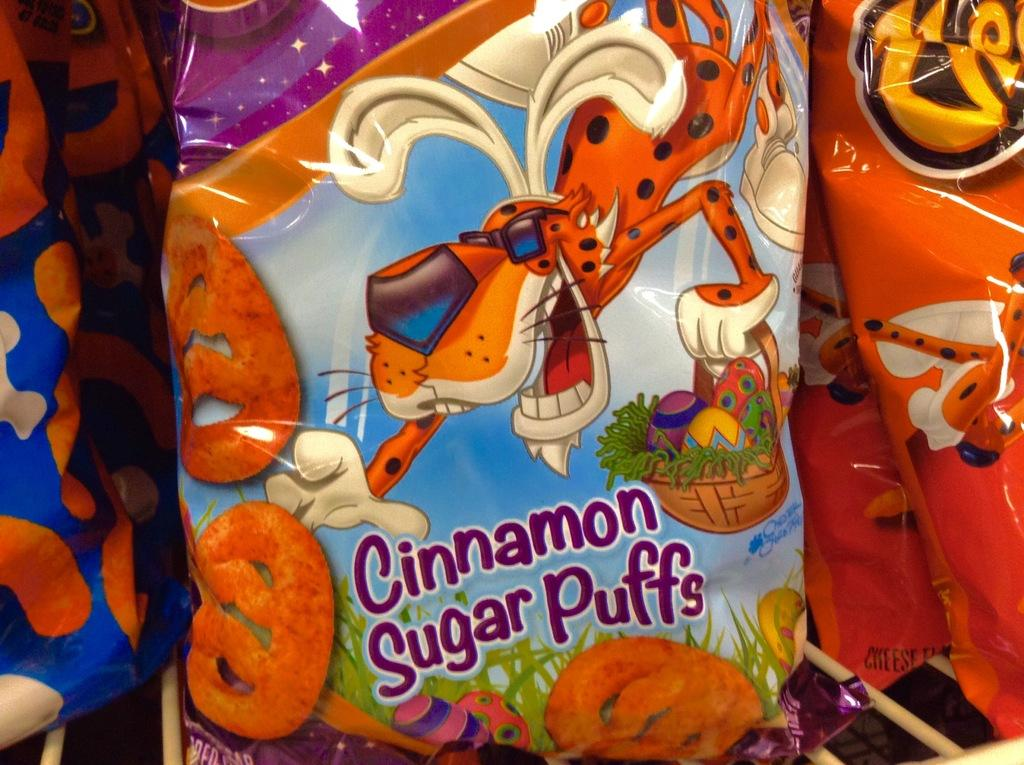What is present in the image related to food? There is a snacks packet in the image. Can you describe the snacks packet in more detail? The snacks packet has cartoon paintings on it. Is there a porter carrying the snacks packet in the image? There is no porter present in the image, and the snacks packet is not being carried by anyone. 